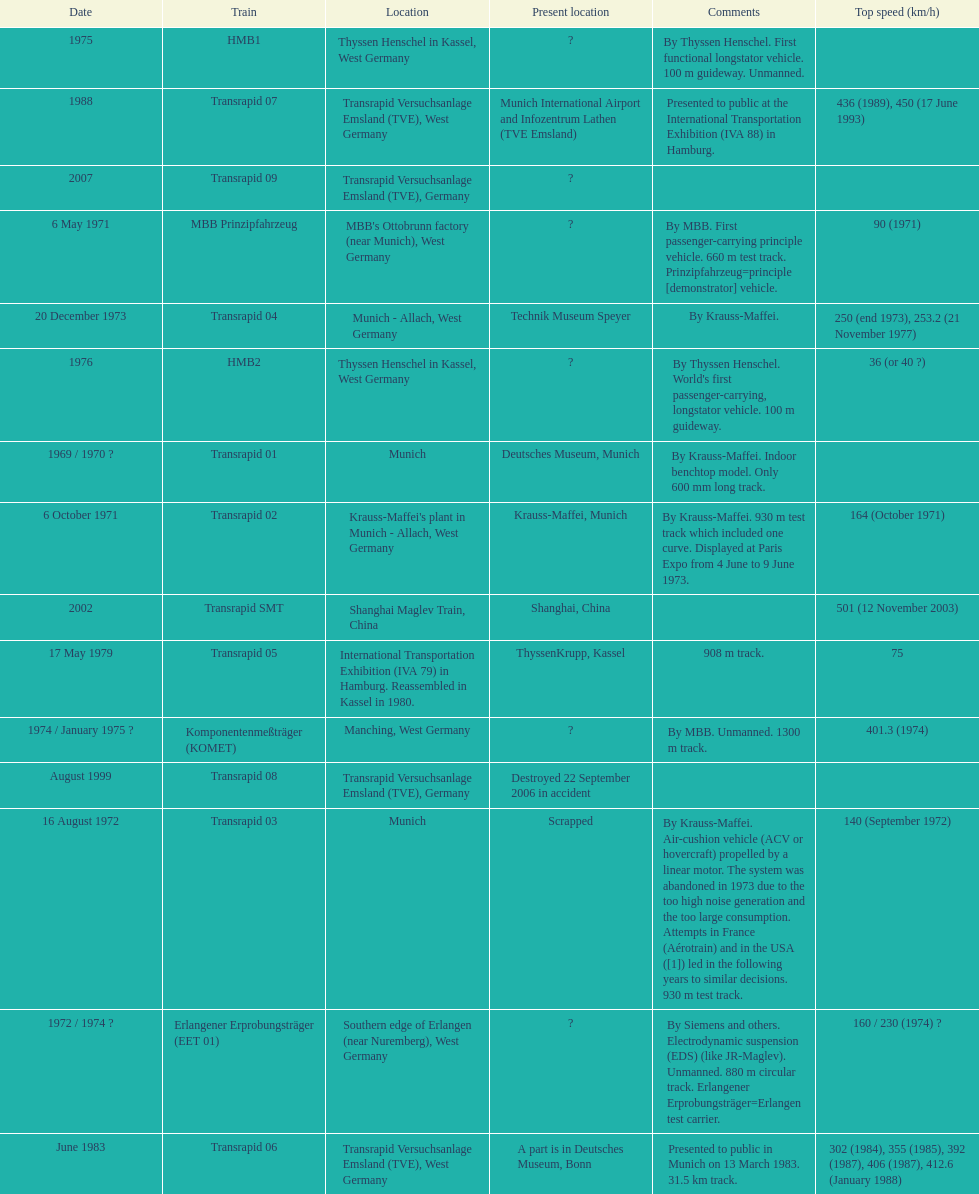What is the only train to reach a top speed of 500 or more? Transrapid SMT. 